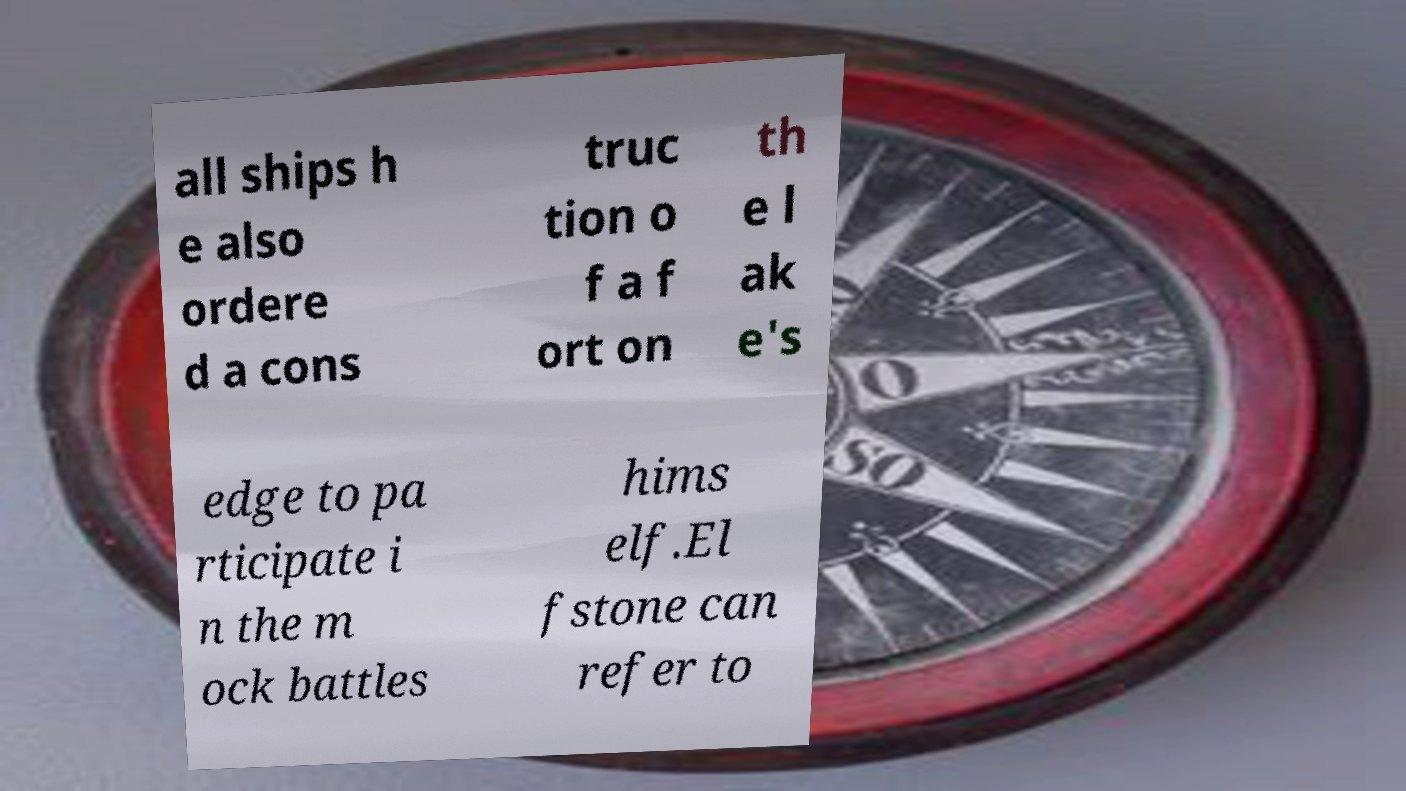Can you read and provide the text displayed in the image?This photo seems to have some interesting text. Can you extract and type it out for me? all ships h e also ordere d a cons truc tion o f a f ort on th e l ak e's edge to pa rticipate i n the m ock battles hims elf.El fstone can refer to 